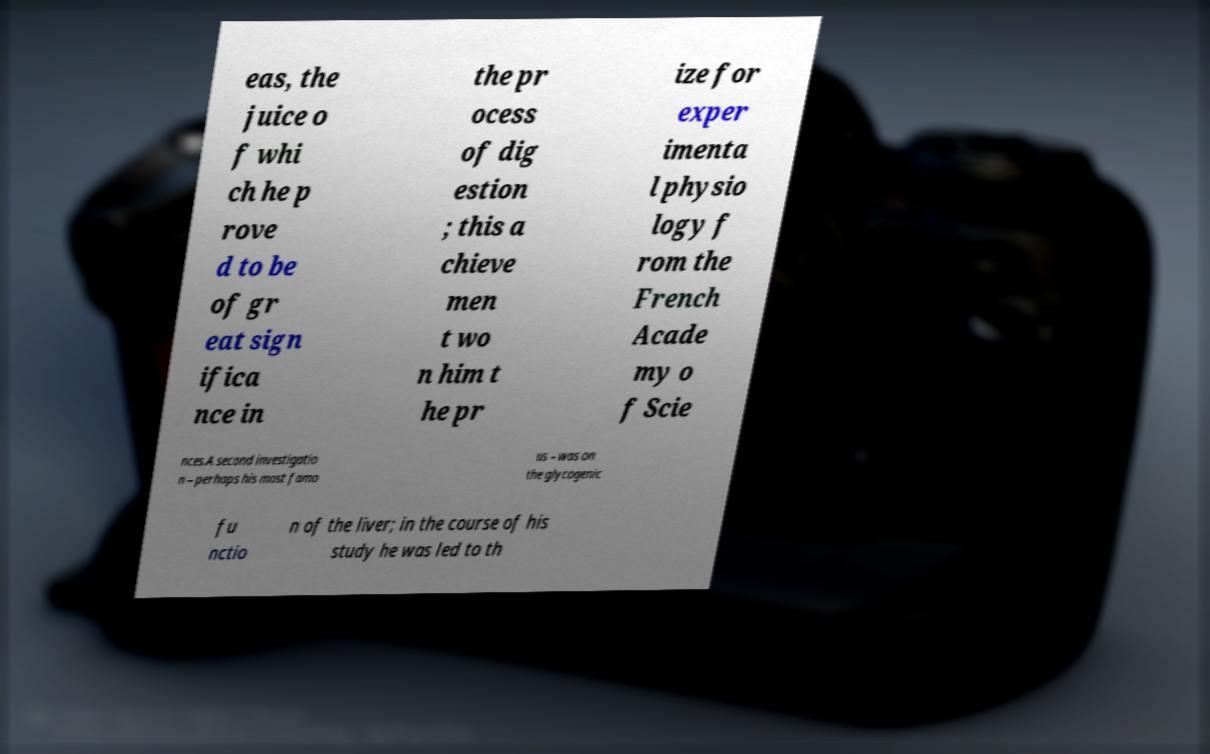Please identify and transcribe the text found in this image. eas, the juice o f whi ch he p rove d to be of gr eat sign ifica nce in the pr ocess of dig estion ; this a chieve men t wo n him t he pr ize for exper imenta l physio logy f rom the French Acade my o f Scie nces.A second investigatio n – perhaps his most famo us – was on the glycogenic fu nctio n of the liver; in the course of his study he was led to th 